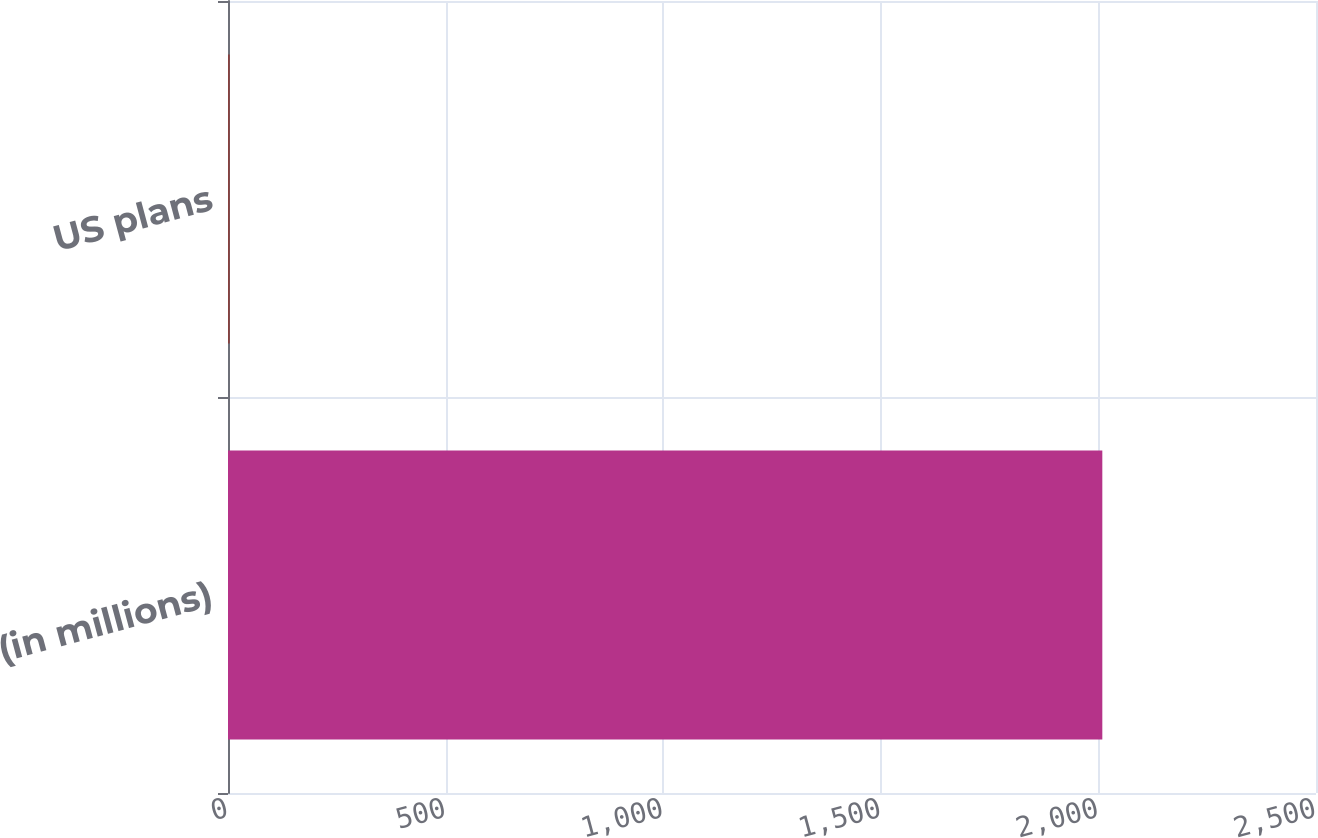Convert chart to OTSL. <chart><loc_0><loc_0><loc_500><loc_500><bar_chart><fcel>(in millions)<fcel>US plans<nl><fcel>2009<fcel>4<nl></chart> 